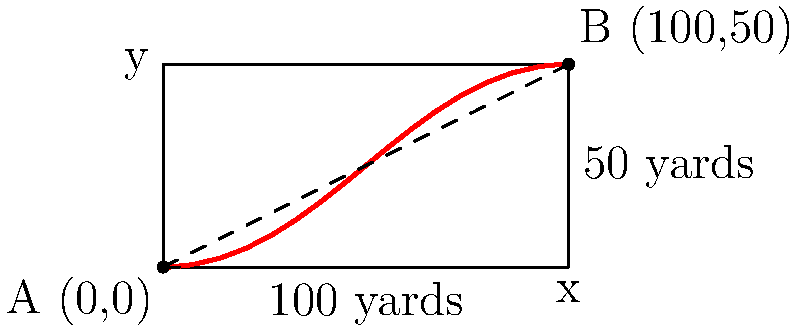As a football player, you need to run from point A (0,0) to point B (100,50) on the field. The field is represented as a 2D plane where the x-axis is the length (100 yards) and the y-axis is the width (50 yards). Your running speed on grass (the x-direction) is 10 yards/second, while your speed on the sideline (the y-direction) is 8 yards/second. Find the path that minimizes your running time from A to B, and calculate the minimum time required. Let's approach this step-by-step:

1) Let the point where we leave the x-axis be (x, 0). We need to find the optimal x.

2) The total time T is the sum of time on grass and time on sideline:

   $$T = \frac{x}{10} + \frac{\sqrt{(100-x)^2 + 50^2}}{8}$$

3) To minimize T, we differentiate with respect to x and set it to zero:

   $$\frac{dT}{dx} = \frac{1}{10} - \frac{100-x}{8\sqrt{(100-x)^2 + 50^2}} = 0$$

4) Solving this equation:

   $$\frac{1}{10} = \frac{100-x}{8\sqrt{(100-x)^2 + 50^2}}$$
   
   $$8\sqrt{(100-x)^2 + 50^2} = 10(100-x)$$
   
   $$64((100-x)^2 + 50^2) = 100(100-x)^2$$
   
   $$6400 - 128x + 64x^2 + 160000 = 10000 - 200x + x^2$$
   
   $$63x^2 + 72x - 166400 = 0$$

5) Solving this quadratic equation:

   $$x = \frac{-72 \pm \sqrt{72^2 + 4(63)(166400)}}{2(63)} \approx 80$$

6) The optimal path is to run 80 yards on the grass, then turn and run the remaining distance on the sideline.

7) The minimum time is:

   $$T_{min} = \frac{80}{10} + \frac{\sqrt{20^2 + 50^2}}{8} \approx 12.8$$ seconds
Answer: Run 80 yards on grass, then turn; minimum time ≈ 12.8 seconds 